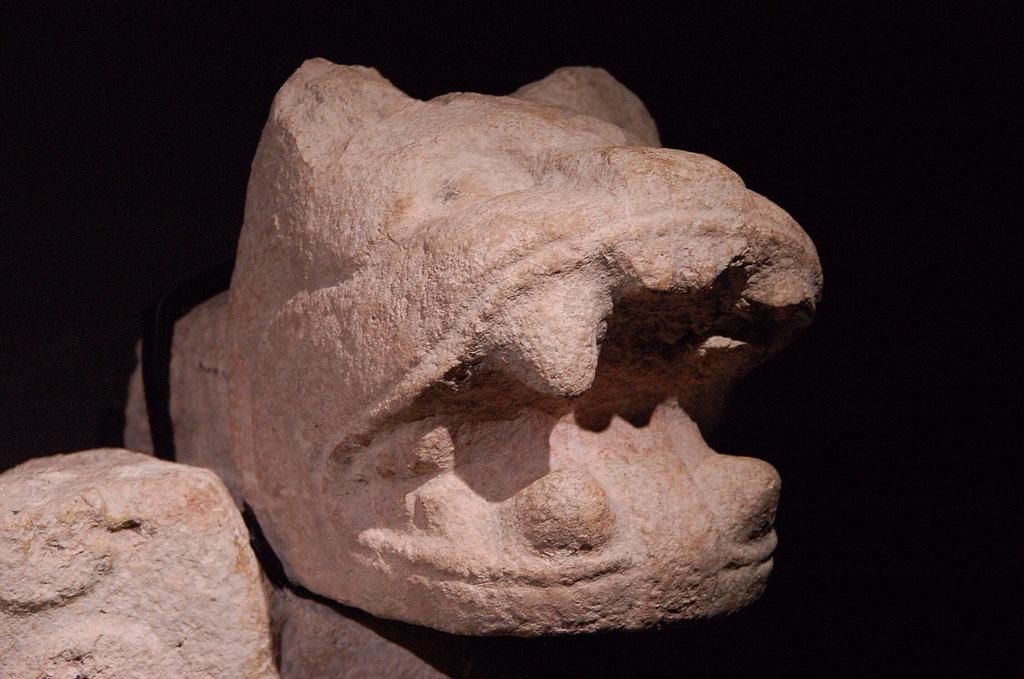What type of natural elements are present in the image? There are rock stones in the image. What type of cork material can be seen in the image? There is no cork material present in the image; it features rock stones. What message is being conveyed with the good-bye gesture in the image? There is no good-bye gesture present in the image, as it only features rock stones. 